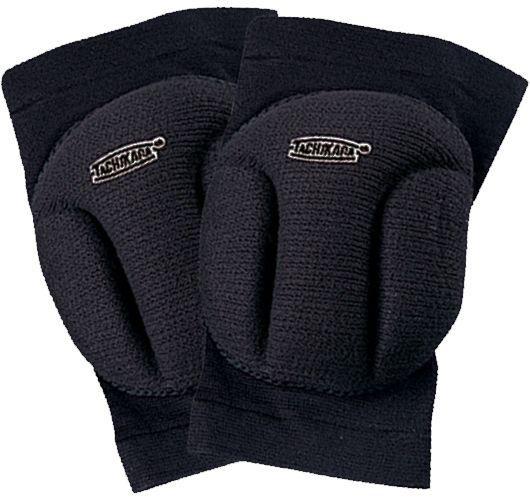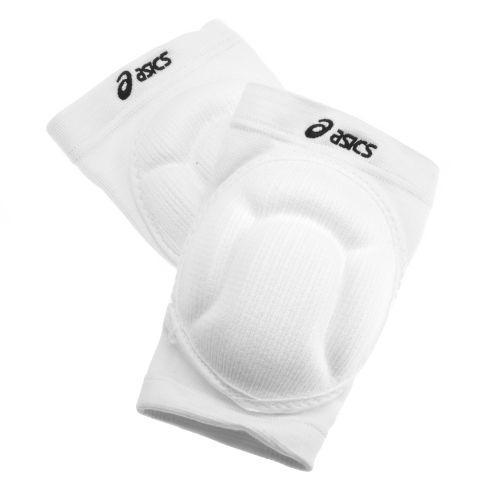The first image is the image on the left, the second image is the image on the right. Considering the images on both sides, is "Each image includes a black knee pad and a white knee pad." valid? Answer yes or no. No. The first image is the image on the left, the second image is the image on the right. Analyze the images presented: Is the assertion "There is one white and one black knee brace in the left image." valid? Answer yes or no. No. 